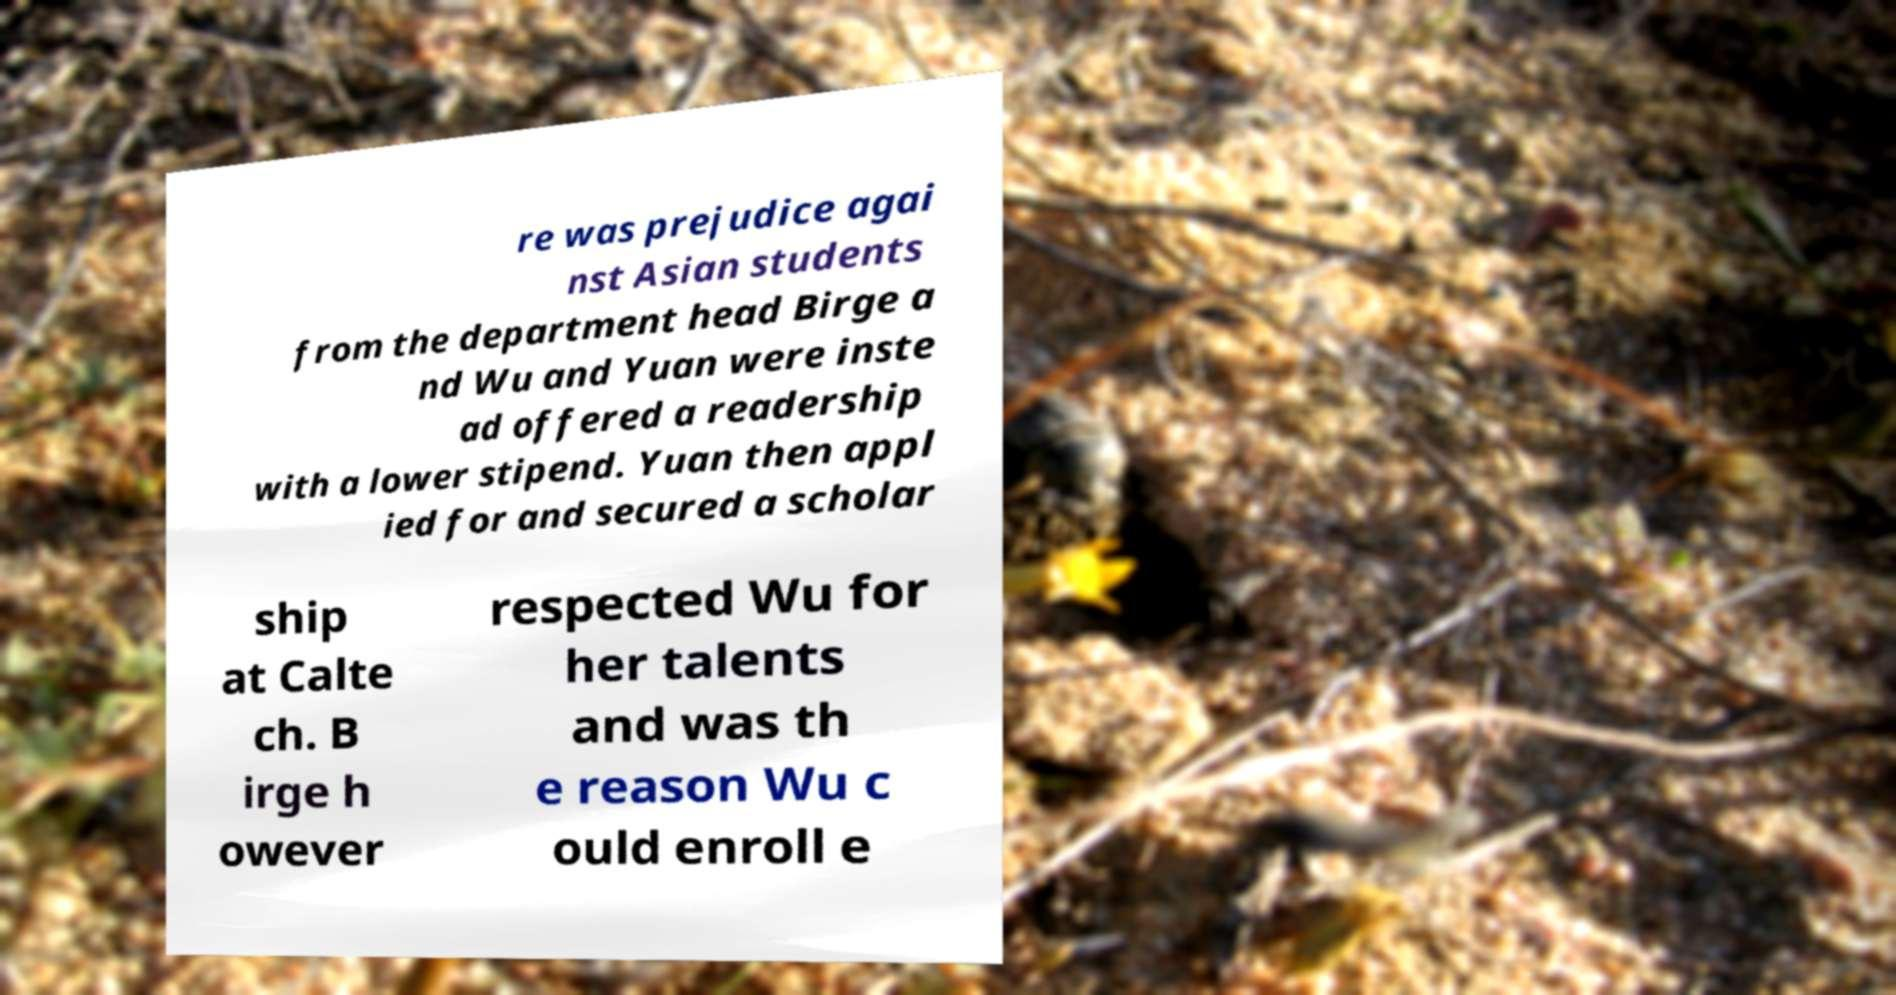For documentation purposes, I need the text within this image transcribed. Could you provide that? re was prejudice agai nst Asian students from the department head Birge a nd Wu and Yuan were inste ad offered a readership with a lower stipend. Yuan then appl ied for and secured a scholar ship at Calte ch. B irge h owever respected Wu for her talents and was th e reason Wu c ould enroll e 